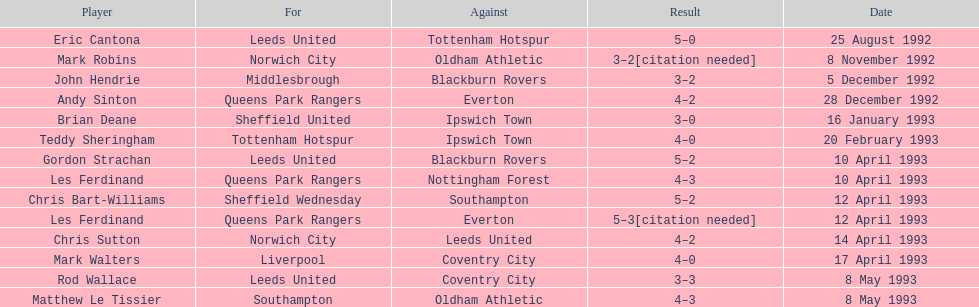Which athlete achieved the same outcome as mark robins? John Hendrie. 